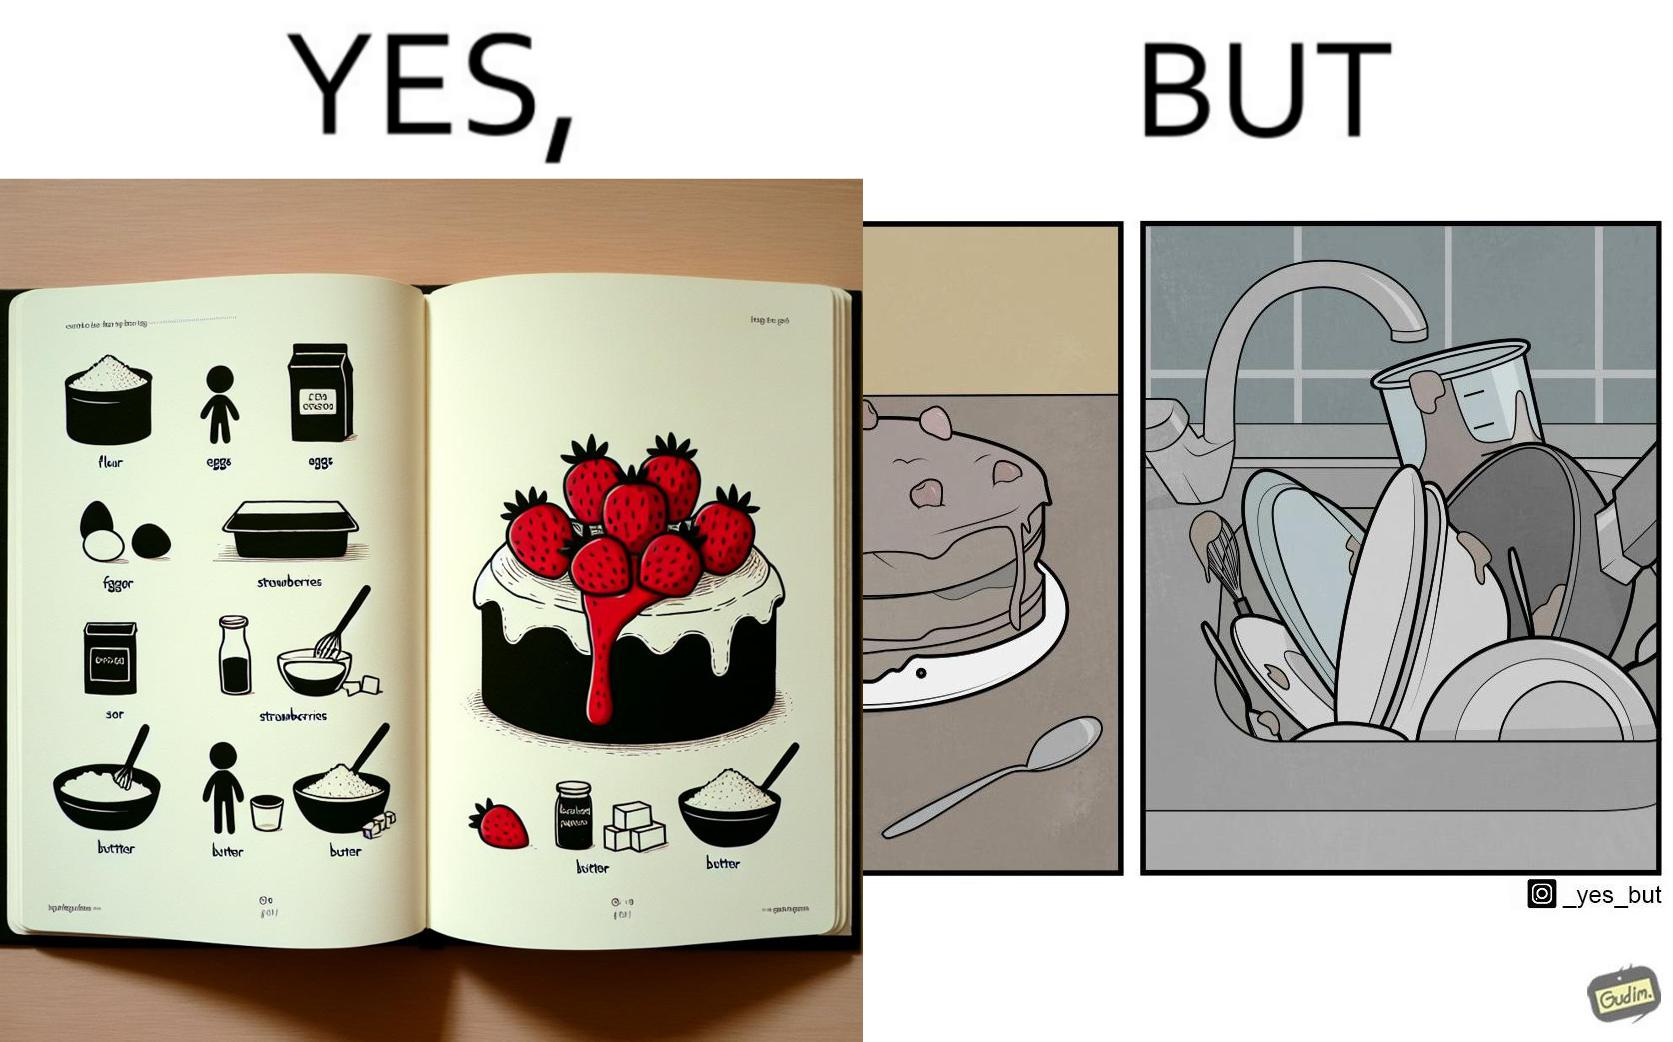What is the satirical meaning behind this image? The image is funny, as when making a strawberry cake using  a recipe book, the outcome is not quite what is expected, and one has to wash the used utensils afterwards as well. 